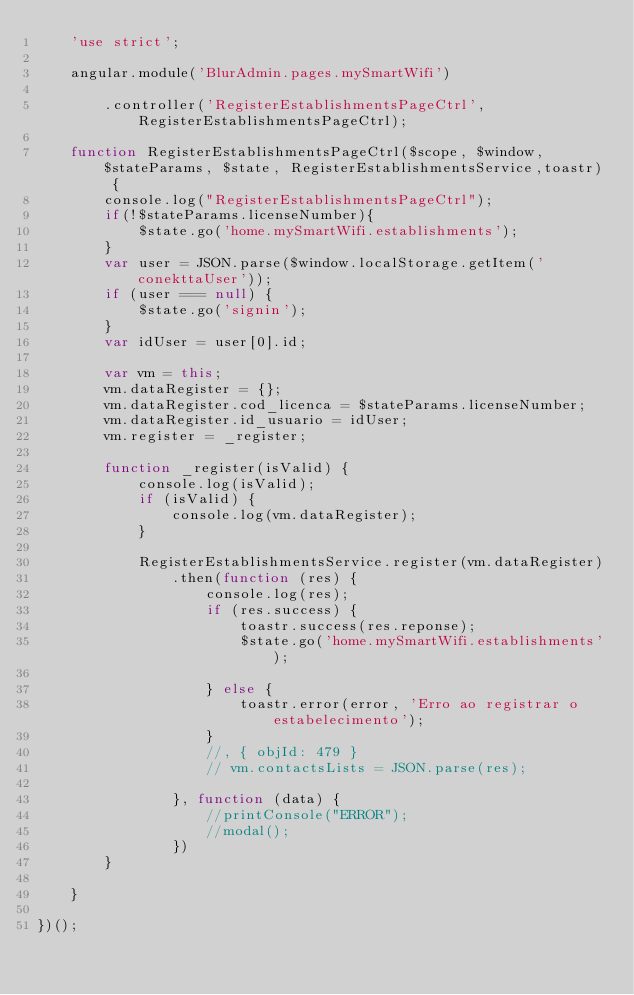Convert code to text. <code><loc_0><loc_0><loc_500><loc_500><_JavaScript_>    'use strict';

    angular.module('BlurAdmin.pages.mySmartWifi')

        .controller('RegisterEstablishmentsPageCtrl', RegisterEstablishmentsPageCtrl);

    function RegisterEstablishmentsPageCtrl($scope, $window, $stateParams, $state, RegisterEstablishmentsService,toastr) {
        console.log("RegisterEstablishmentsPageCtrl");
        if(!$stateParams.licenseNumber){
            $state.go('home.mySmartWifi.establishments');
        }
        var user = JSON.parse($window.localStorage.getItem('conekttaUser'));
        if (user === null) {
            $state.go('signin');
        }
        var idUser = user[0].id;

        var vm = this;
        vm.dataRegister = {};
        vm.dataRegister.cod_licenca = $stateParams.licenseNumber;
        vm.dataRegister.id_usuario = idUser;
        vm.register = _register;

        function _register(isValid) {
            console.log(isValid);
            if (isValid) {
                console.log(vm.dataRegister);
            }

            RegisterEstablishmentsService.register(vm.dataRegister)
                .then(function (res) {
                    console.log(res);
                    if (res.success) {
                        toastr.success(res.reponse);
                        $state.go('home.mySmartWifi.establishments');

                    } else {
                        toastr.error(error, 'Erro ao registrar o estabelecimento');
                    }
                    //, { objId: 479 }
                    // vm.contactsLists = JSON.parse(res);

                }, function (data) {
                    //printConsole("ERROR");
                    //modal();
                })
        }

    }

})();

</code> 